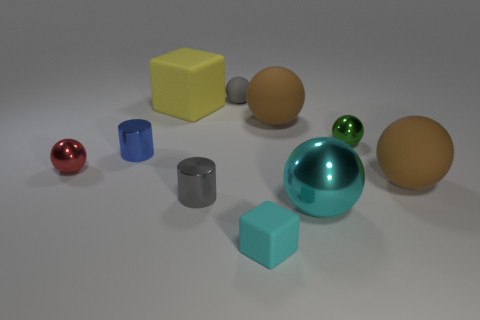There is a tiny red thing that is the same shape as the small green thing; what is it made of?
Your answer should be compact. Metal. Are there more brown things on the left side of the small gray cylinder than tiny green objects?
Provide a succinct answer. No. Is there any other thing that is the same color as the small rubber block?
Give a very brief answer. Yes. There is a blue object that is the same material as the tiny green sphere; what shape is it?
Make the answer very short. Cylinder. Is the material of the tiny sphere to the left of the yellow rubber cube the same as the small cyan cube?
Your answer should be very brief. No. What is the shape of the large thing that is the same color as the tiny block?
Offer a terse response. Sphere. Does the small ball that is in front of the green ball have the same color as the small metallic thing that is on the right side of the big cyan sphere?
Make the answer very short. No. What number of matte things are behind the yellow rubber thing and on the left side of the small gray matte object?
Ensure brevity in your answer.  0. What is the green object made of?
Keep it short and to the point. Metal. What shape is the other metallic thing that is the same size as the yellow thing?
Provide a short and direct response. Sphere. 